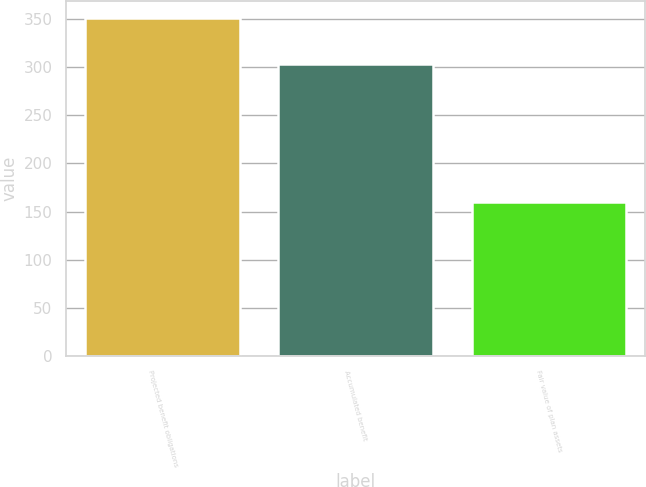<chart> <loc_0><loc_0><loc_500><loc_500><bar_chart><fcel>Projected benefit obligations<fcel>Accumulated benefit<fcel>Fair value of plan assets<nl><fcel>351<fcel>303<fcel>160<nl></chart> 